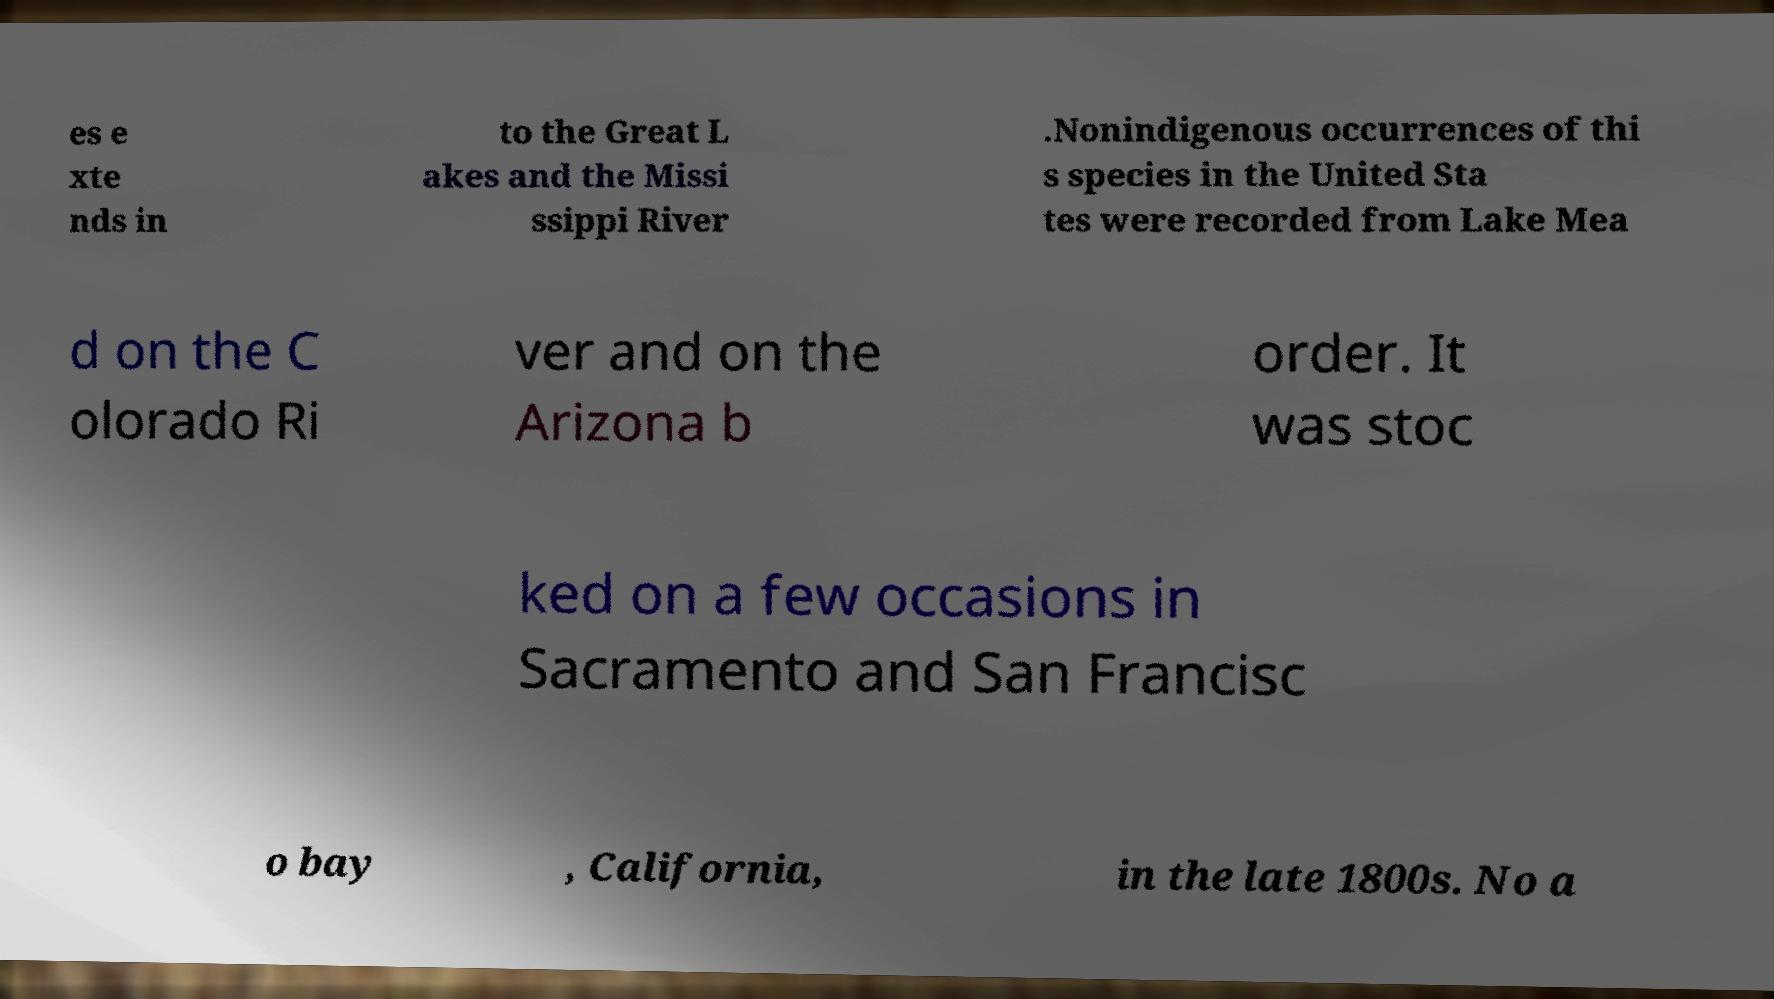What messages or text are displayed in this image? I need them in a readable, typed format. es e xte nds in to the Great L akes and the Missi ssippi River .Nonindigenous occurrences of thi s species in the United Sta tes were recorded from Lake Mea d on the C olorado Ri ver and on the Arizona b order. It was stoc ked on a few occasions in Sacramento and San Francisc o bay , California, in the late 1800s. No a 